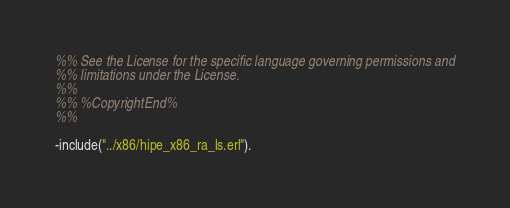<code> <loc_0><loc_0><loc_500><loc_500><_Erlang_>%% See the License for the specific language governing permissions and
%% limitations under the License.
%% 
%% %CopyrightEnd%
%%

-include("../x86/hipe_x86_ra_ls.erl").
</code> 